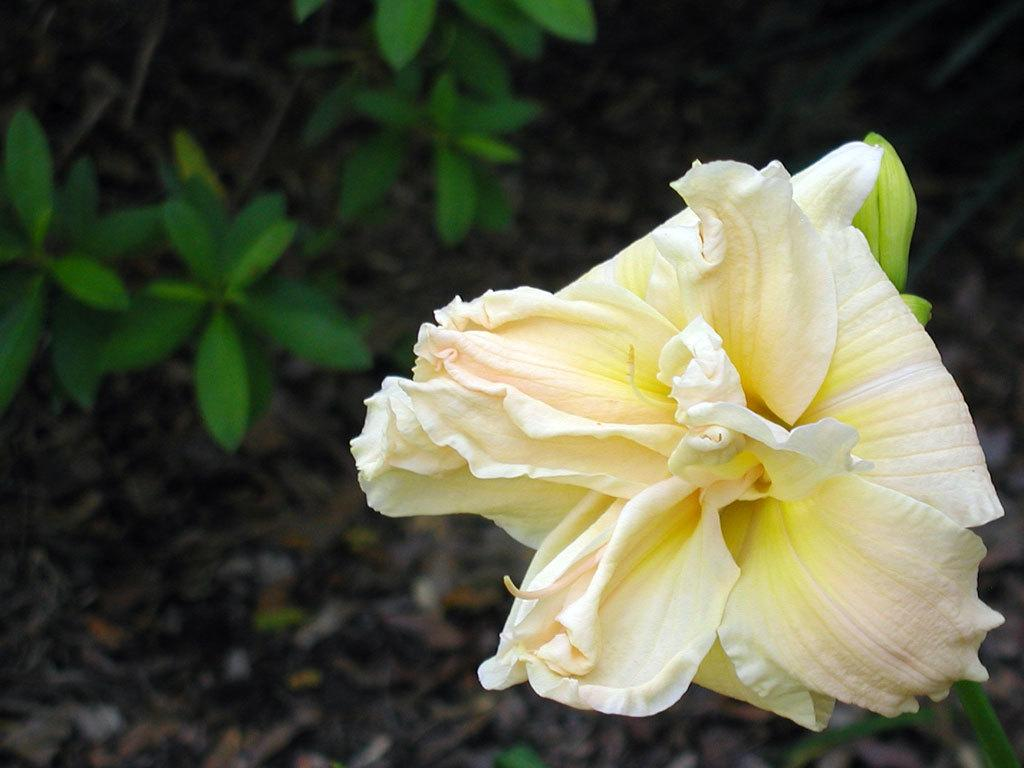What type of flower is present in the image? There is a yellow and white flower in the image. What else can be seen in the image besides the flower? There are leaves of plants in the image. Where are the leaves located in the image? The leaves are on the left side of the image. What is present at the bottom of the image? The bottom of the image contains dried leaves. Can you see a tiger using a toothbrush in the image? No, there is no tiger or toothbrush present in the image. 